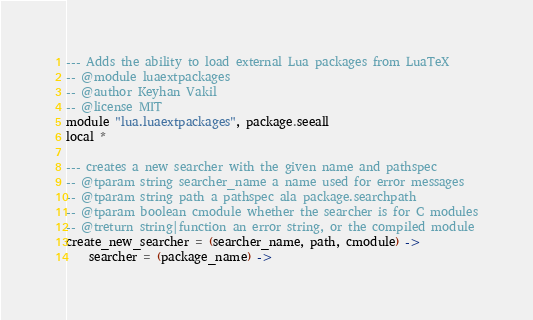<code> <loc_0><loc_0><loc_500><loc_500><_MoonScript_>--- Adds the ability to load external Lua packages from LuaTeX
-- @module luaextpackages
-- @author Keyhan Vakil
-- @license MIT
module "lua.luaextpackages", package.seeall
local *

--- creates a new searcher with the given name and pathspec
-- @tparam string searcher_name a name used for error messages
-- @tparam string path a pathspec ala package.searchpath
-- @tparam boolean cmodule whether the searcher is for C modules
-- @treturn string|function an error string, or the compiled module
create_new_searcher = (searcher_name, path, cmodule) ->
    searcher = (package_name) -></code> 